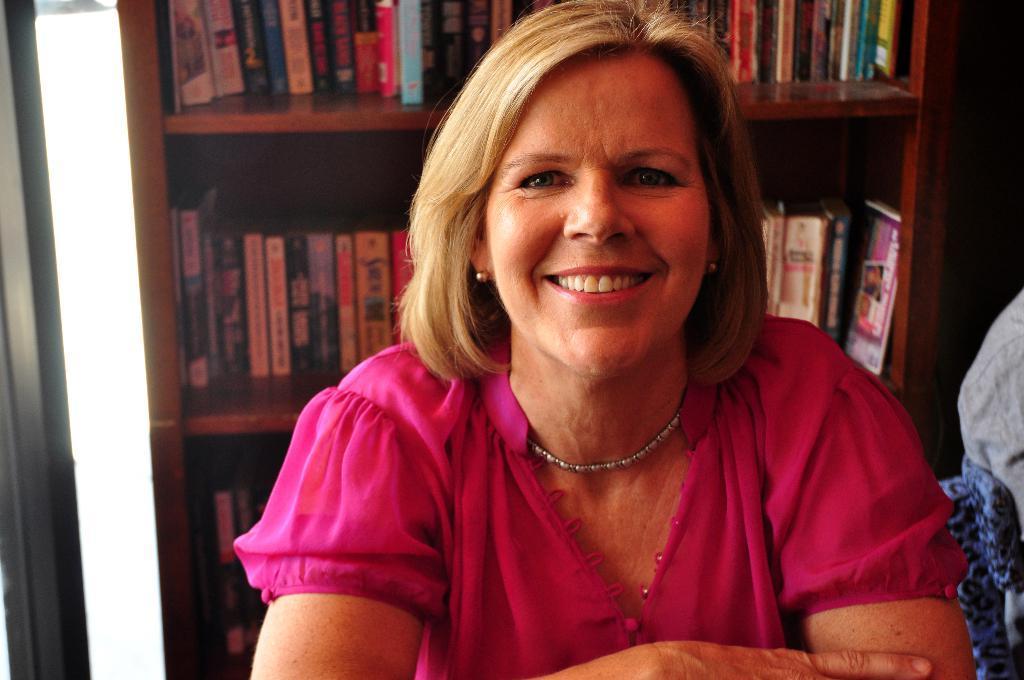Can you describe this image briefly? In this picture I can observe a woman in the middle of the picture. She is wearing pink color dress. Woman is smiling. Behind her I can observe books placed in the shelf. 